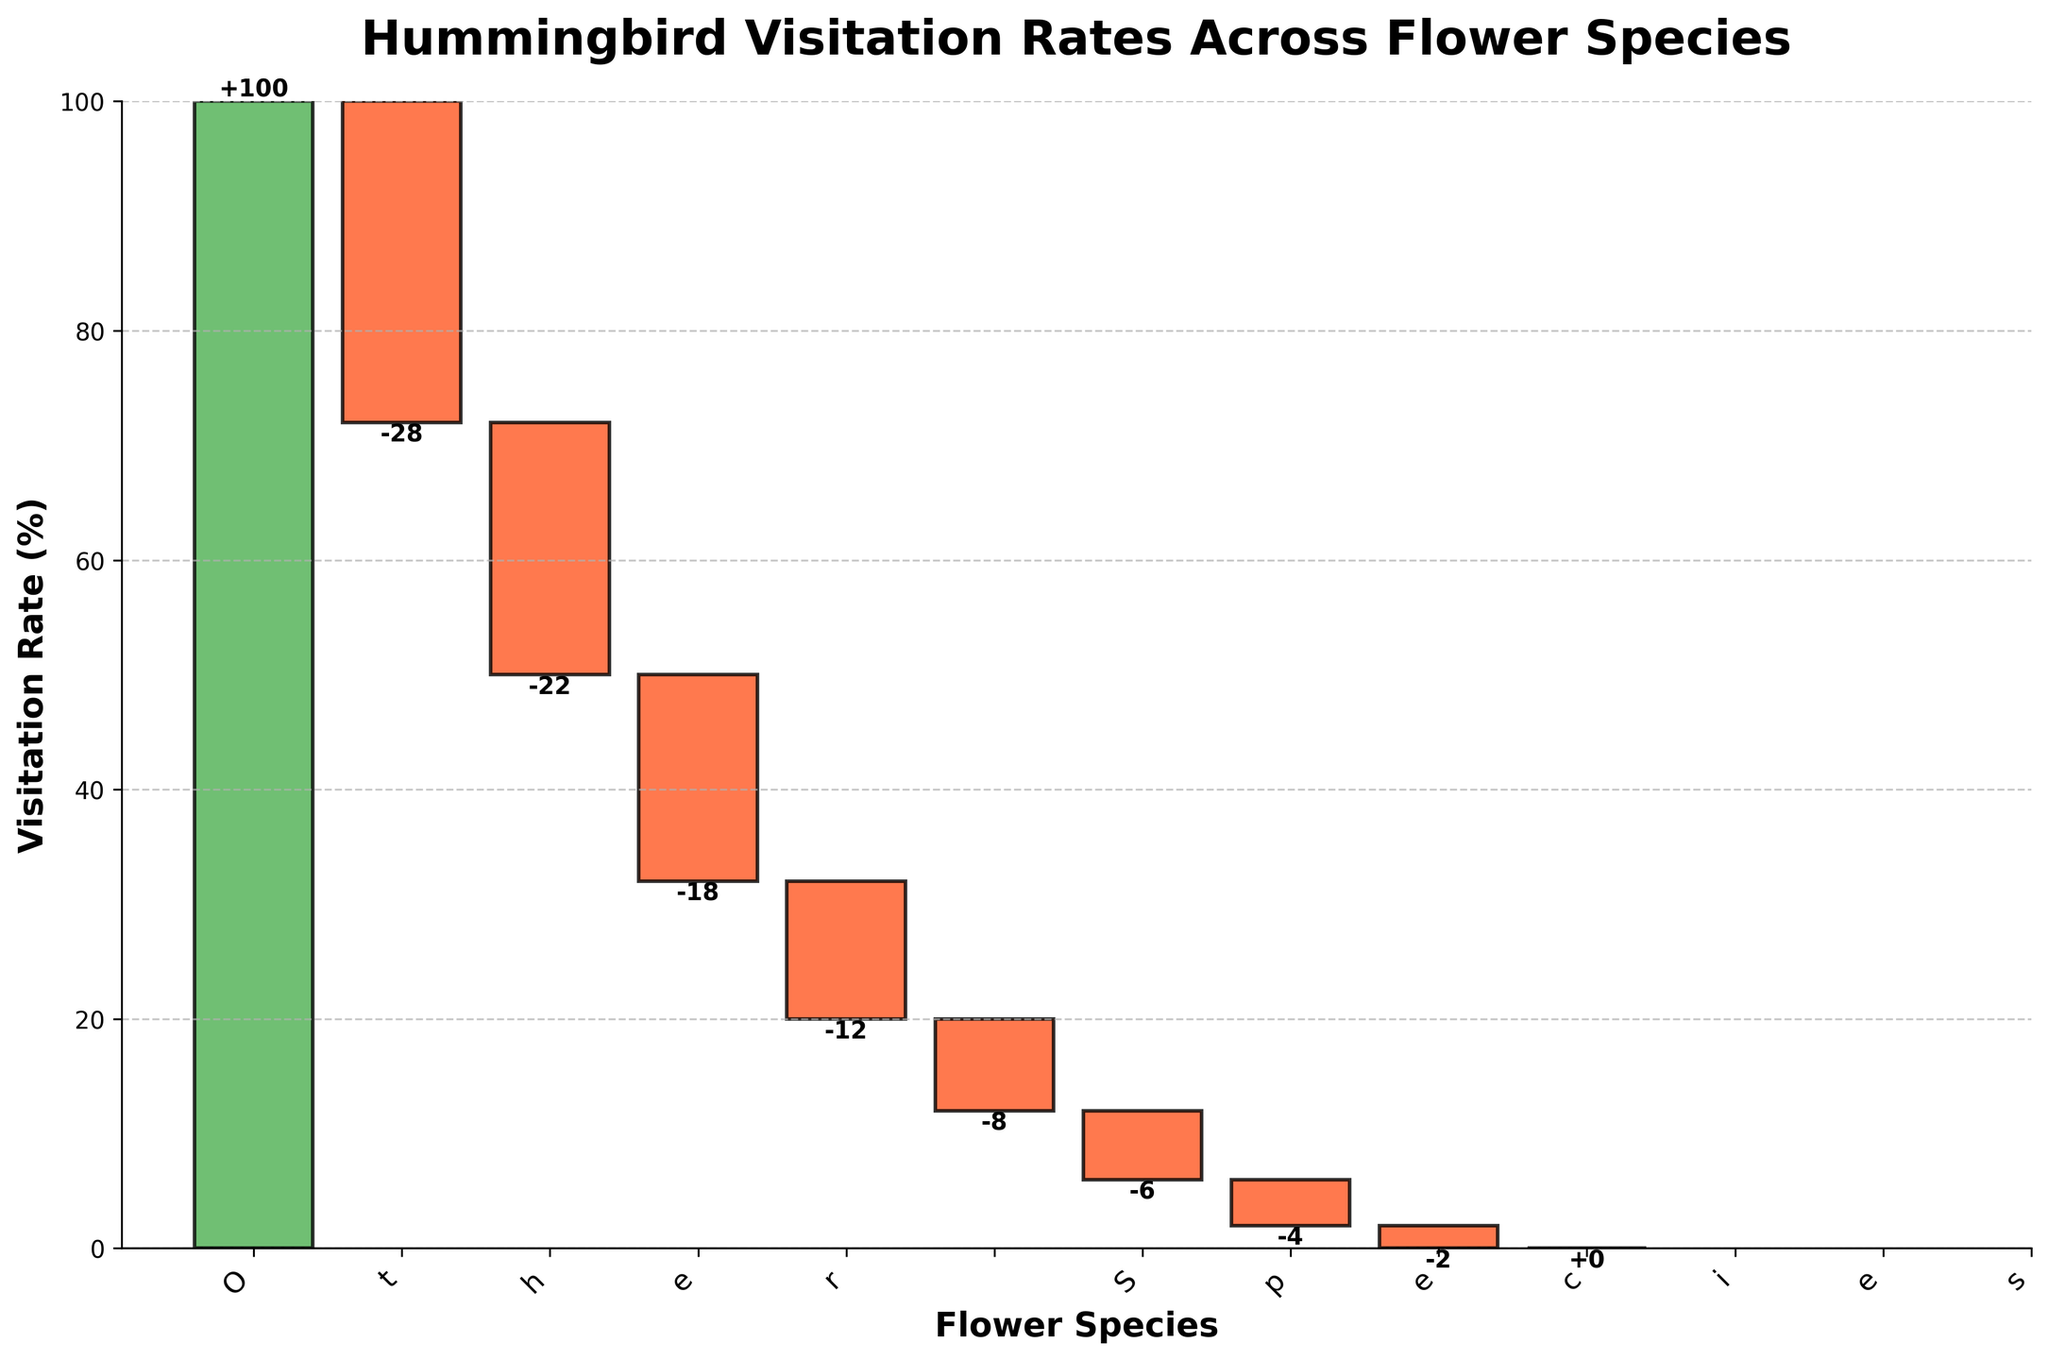What is the title of the chart? The title of the chart is displayed at the top and reads "Hummingbird Visitation Rates Across Flower Species."
Answer: Hummingbird Visitation Rates Across Flower Species What is the visitation rate for Trumpet Honeysuckle? The chart shows individual bars for each species with their visitation rate labeled. Trumpet Honeysuckle has a visitation rate of -28%.
Answer: -28% Which species has the least negative impact on visitation rates? Reviewing the chart, the species with the smallest negative value is Salvia, with a visitation rate of -2%.
Answer: Salvia What is the cumulative effect of Trumpet Honeysuckle and Cardinal Flower on the total visitation rate? To find the cumulative effect, sum the visitation rates of Trumpet Honeysuckle (-28%) and Cardinal Flower (-22%): -28% + -22% = -50%.
Answer: -50% Which species had a visitation rate closest to -10%? Based on the chart, Columbine has a visitation rate closest to -10% with a rate of -12%.
Answer: Columbine Out of all the species, which one had no change in visitation rate? By examining the end of the bars, "Other Species" had a visitation rate of 0%, indicating no change.
Answer: Other Species How does the visitation rate of Coral Bells compare to that of Penstemon? The chart shows that Coral Bells have a rate of -8%, while Penstemon has a rate of -6%. Therefore, Coral Bells have a more negative rate compared to Penstemon.
Answer: Coral Bells is more negative What is the total negative contribution to the visitation rate from all flower species? Add up the visitation rates of all species except "Total" and "Other Species" (-28% + -22% + -18% + -12% + -8% + -6% + -4% + -2%): -28 -22 -18 -12 -8 -6 -4 -2 = -100%.
Answer: -100% How can one identify the species with the highest and lowest contributions on the chart? On a waterfall chart, the highest contributions are the largest bars, and the lowest are the smallest. Trumpet Honeysuckle has the largest negative bar at -28%, and Salvia has the smallest negative bar at -2%.
Answer: Trumpet Honeysuckle (highest negative), Salvia (lowest negative) How many flower species were analyzed in total? Counting all individual bars labeled with species names on the x-axis, there are eight flower species listed.
Answer: Eight 